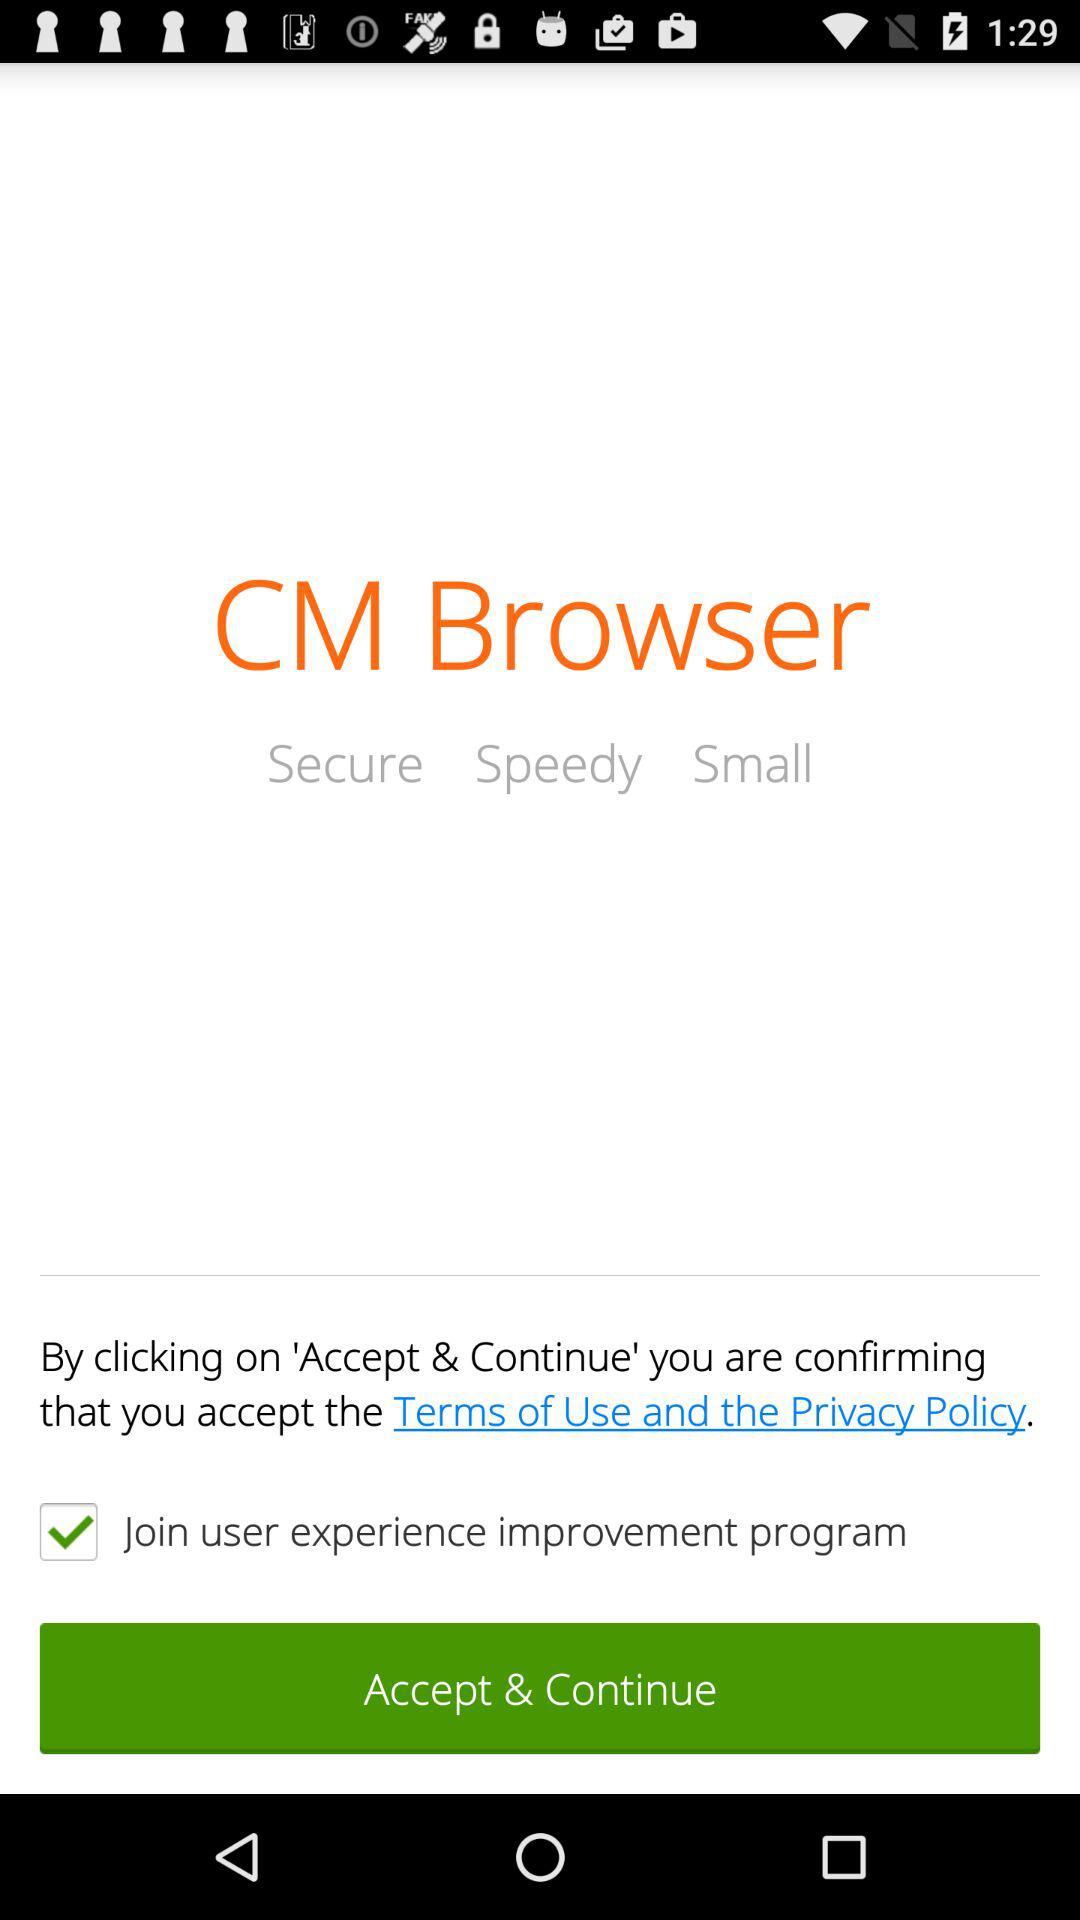What is the app name? The app name is "CM Browser". 